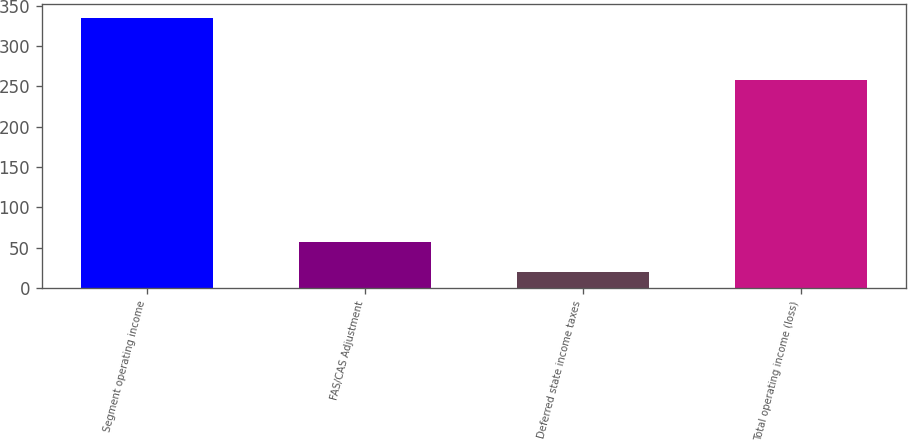Convert chart to OTSL. <chart><loc_0><loc_0><loc_500><loc_500><bar_chart><fcel>Segment operating income<fcel>FAS/CAS Adjustment<fcel>Deferred state income taxes<fcel>Total operating income (loss)<nl><fcel>335<fcel>57<fcel>20<fcel>258<nl></chart> 